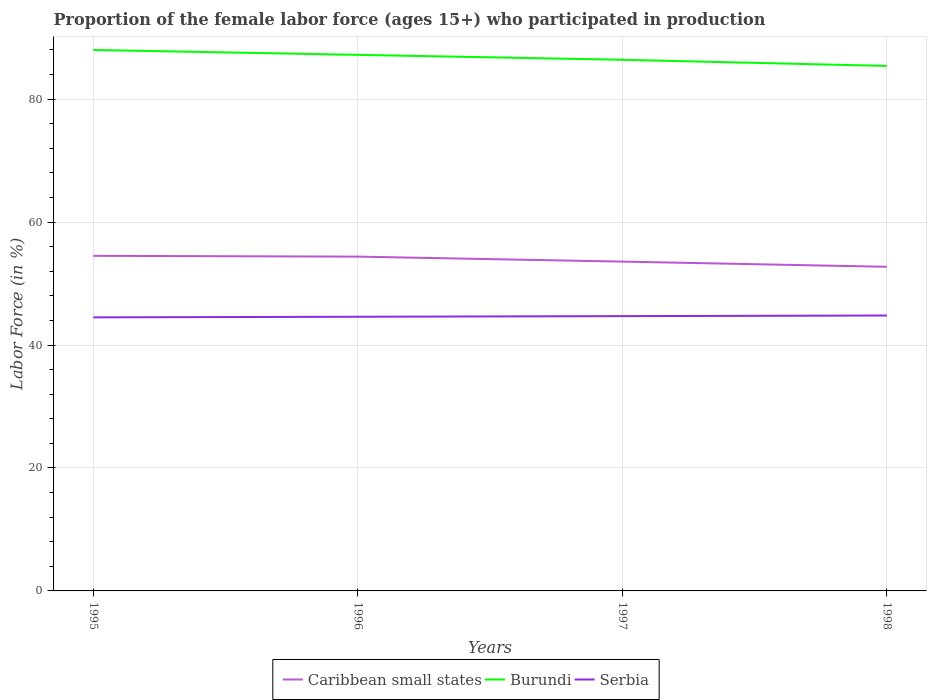How many different coloured lines are there?
Provide a succinct answer. 3. Does the line corresponding to Caribbean small states intersect with the line corresponding to Burundi?
Give a very brief answer. No. Is the number of lines equal to the number of legend labels?
Ensure brevity in your answer.  Yes. Across all years, what is the maximum proportion of the female labor force who participated in production in Caribbean small states?
Offer a very short reply. 52.73. What is the total proportion of the female labor force who participated in production in Burundi in the graph?
Offer a very short reply. 1.8. What is the difference between the highest and the second highest proportion of the female labor force who participated in production in Serbia?
Keep it short and to the point. 0.3. What is the difference between the highest and the lowest proportion of the female labor force who participated in production in Burundi?
Give a very brief answer. 2. How many lines are there?
Provide a short and direct response. 3. How many years are there in the graph?
Offer a terse response. 4. Are the values on the major ticks of Y-axis written in scientific E-notation?
Provide a short and direct response. No. Does the graph contain grids?
Offer a very short reply. Yes. Where does the legend appear in the graph?
Make the answer very short. Bottom center. What is the title of the graph?
Provide a short and direct response. Proportion of the female labor force (ages 15+) who participated in production. What is the label or title of the Y-axis?
Provide a succinct answer. Labor Force (in %). What is the Labor Force (in %) in Caribbean small states in 1995?
Your answer should be compact. 54.51. What is the Labor Force (in %) of Serbia in 1995?
Give a very brief answer. 44.5. What is the Labor Force (in %) in Caribbean small states in 1996?
Give a very brief answer. 54.38. What is the Labor Force (in %) of Burundi in 1996?
Give a very brief answer. 87.2. What is the Labor Force (in %) in Serbia in 1996?
Give a very brief answer. 44.6. What is the Labor Force (in %) in Caribbean small states in 1997?
Your answer should be compact. 53.57. What is the Labor Force (in %) of Burundi in 1997?
Your answer should be compact. 86.4. What is the Labor Force (in %) in Serbia in 1997?
Provide a succinct answer. 44.7. What is the Labor Force (in %) of Caribbean small states in 1998?
Provide a succinct answer. 52.73. What is the Labor Force (in %) of Burundi in 1998?
Offer a very short reply. 85.4. What is the Labor Force (in %) in Serbia in 1998?
Your answer should be very brief. 44.8. Across all years, what is the maximum Labor Force (in %) in Caribbean small states?
Ensure brevity in your answer.  54.51. Across all years, what is the maximum Labor Force (in %) in Burundi?
Provide a short and direct response. 88. Across all years, what is the maximum Labor Force (in %) of Serbia?
Make the answer very short. 44.8. Across all years, what is the minimum Labor Force (in %) in Caribbean small states?
Keep it short and to the point. 52.73. Across all years, what is the minimum Labor Force (in %) in Burundi?
Your answer should be compact. 85.4. Across all years, what is the minimum Labor Force (in %) of Serbia?
Give a very brief answer. 44.5. What is the total Labor Force (in %) in Caribbean small states in the graph?
Ensure brevity in your answer.  215.19. What is the total Labor Force (in %) of Burundi in the graph?
Offer a very short reply. 347. What is the total Labor Force (in %) of Serbia in the graph?
Offer a very short reply. 178.6. What is the difference between the Labor Force (in %) in Caribbean small states in 1995 and that in 1996?
Offer a terse response. 0.13. What is the difference between the Labor Force (in %) in Burundi in 1995 and that in 1996?
Provide a short and direct response. 0.8. What is the difference between the Labor Force (in %) of Serbia in 1995 and that in 1996?
Give a very brief answer. -0.1. What is the difference between the Labor Force (in %) in Caribbean small states in 1995 and that in 1997?
Keep it short and to the point. 0.94. What is the difference between the Labor Force (in %) in Burundi in 1995 and that in 1997?
Your response must be concise. 1.6. What is the difference between the Labor Force (in %) in Serbia in 1995 and that in 1997?
Make the answer very short. -0.2. What is the difference between the Labor Force (in %) of Caribbean small states in 1995 and that in 1998?
Your answer should be very brief. 1.78. What is the difference between the Labor Force (in %) in Serbia in 1995 and that in 1998?
Your response must be concise. -0.3. What is the difference between the Labor Force (in %) in Caribbean small states in 1996 and that in 1997?
Make the answer very short. 0.81. What is the difference between the Labor Force (in %) of Burundi in 1996 and that in 1997?
Offer a terse response. 0.8. What is the difference between the Labor Force (in %) in Serbia in 1996 and that in 1997?
Offer a very short reply. -0.1. What is the difference between the Labor Force (in %) in Caribbean small states in 1996 and that in 1998?
Keep it short and to the point. 1.65. What is the difference between the Labor Force (in %) of Burundi in 1996 and that in 1998?
Provide a short and direct response. 1.8. What is the difference between the Labor Force (in %) of Serbia in 1996 and that in 1998?
Make the answer very short. -0.2. What is the difference between the Labor Force (in %) of Caribbean small states in 1997 and that in 1998?
Give a very brief answer. 0.84. What is the difference between the Labor Force (in %) of Burundi in 1997 and that in 1998?
Offer a very short reply. 1. What is the difference between the Labor Force (in %) in Serbia in 1997 and that in 1998?
Give a very brief answer. -0.1. What is the difference between the Labor Force (in %) in Caribbean small states in 1995 and the Labor Force (in %) in Burundi in 1996?
Offer a very short reply. -32.69. What is the difference between the Labor Force (in %) in Caribbean small states in 1995 and the Labor Force (in %) in Serbia in 1996?
Give a very brief answer. 9.91. What is the difference between the Labor Force (in %) of Burundi in 1995 and the Labor Force (in %) of Serbia in 1996?
Keep it short and to the point. 43.4. What is the difference between the Labor Force (in %) in Caribbean small states in 1995 and the Labor Force (in %) in Burundi in 1997?
Keep it short and to the point. -31.89. What is the difference between the Labor Force (in %) of Caribbean small states in 1995 and the Labor Force (in %) of Serbia in 1997?
Offer a terse response. 9.81. What is the difference between the Labor Force (in %) in Burundi in 1995 and the Labor Force (in %) in Serbia in 1997?
Your answer should be very brief. 43.3. What is the difference between the Labor Force (in %) in Caribbean small states in 1995 and the Labor Force (in %) in Burundi in 1998?
Your response must be concise. -30.89. What is the difference between the Labor Force (in %) in Caribbean small states in 1995 and the Labor Force (in %) in Serbia in 1998?
Your answer should be very brief. 9.71. What is the difference between the Labor Force (in %) in Burundi in 1995 and the Labor Force (in %) in Serbia in 1998?
Keep it short and to the point. 43.2. What is the difference between the Labor Force (in %) of Caribbean small states in 1996 and the Labor Force (in %) of Burundi in 1997?
Provide a short and direct response. -32.02. What is the difference between the Labor Force (in %) of Caribbean small states in 1996 and the Labor Force (in %) of Serbia in 1997?
Provide a succinct answer. 9.68. What is the difference between the Labor Force (in %) in Burundi in 1996 and the Labor Force (in %) in Serbia in 1997?
Make the answer very short. 42.5. What is the difference between the Labor Force (in %) in Caribbean small states in 1996 and the Labor Force (in %) in Burundi in 1998?
Your answer should be compact. -31.02. What is the difference between the Labor Force (in %) of Caribbean small states in 1996 and the Labor Force (in %) of Serbia in 1998?
Ensure brevity in your answer.  9.58. What is the difference between the Labor Force (in %) of Burundi in 1996 and the Labor Force (in %) of Serbia in 1998?
Make the answer very short. 42.4. What is the difference between the Labor Force (in %) of Caribbean small states in 1997 and the Labor Force (in %) of Burundi in 1998?
Your response must be concise. -31.83. What is the difference between the Labor Force (in %) in Caribbean small states in 1997 and the Labor Force (in %) in Serbia in 1998?
Ensure brevity in your answer.  8.77. What is the difference between the Labor Force (in %) of Burundi in 1997 and the Labor Force (in %) of Serbia in 1998?
Provide a succinct answer. 41.6. What is the average Labor Force (in %) of Caribbean small states per year?
Make the answer very short. 53.8. What is the average Labor Force (in %) in Burundi per year?
Make the answer very short. 86.75. What is the average Labor Force (in %) in Serbia per year?
Ensure brevity in your answer.  44.65. In the year 1995, what is the difference between the Labor Force (in %) in Caribbean small states and Labor Force (in %) in Burundi?
Make the answer very short. -33.49. In the year 1995, what is the difference between the Labor Force (in %) of Caribbean small states and Labor Force (in %) of Serbia?
Offer a very short reply. 10.01. In the year 1995, what is the difference between the Labor Force (in %) of Burundi and Labor Force (in %) of Serbia?
Your answer should be compact. 43.5. In the year 1996, what is the difference between the Labor Force (in %) of Caribbean small states and Labor Force (in %) of Burundi?
Provide a succinct answer. -32.82. In the year 1996, what is the difference between the Labor Force (in %) in Caribbean small states and Labor Force (in %) in Serbia?
Your answer should be very brief. 9.78. In the year 1996, what is the difference between the Labor Force (in %) in Burundi and Labor Force (in %) in Serbia?
Your answer should be compact. 42.6. In the year 1997, what is the difference between the Labor Force (in %) of Caribbean small states and Labor Force (in %) of Burundi?
Provide a short and direct response. -32.83. In the year 1997, what is the difference between the Labor Force (in %) in Caribbean small states and Labor Force (in %) in Serbia?
Offer a very short reply. 8.87. In the year 1997, what is the difference between the Labor Force (in %) of Burundi and Labor Force (in %) of Serbia?
Give a very brief answer. 41.7. In the year 1998, what is the difference between the Labor Force (in %) of Caribbean small states and Labor Force (in %) of Burundi?
Keep it short and to the point. -32.67. In the year 1998, what is the difference between the Labor Force (in %) in Caribbean small states and Labor Force (in %) in Serbia?
Give a very brief answer. 7.93. In the year 1998, what is the difference between the Labor Force (in %) in Burundi and Labor Force (in %) in Serbia?
Your answer should be compact. 40.6. What is the ratio of the Labor Force (in %) of Burundi in 1995 to that in 1996?
Provide a succinct answer. 1.01. What is the ratio of the Labor Force (in %) in Caribbean small states in 1995 to that in 1997?
Provide a short and direct response. 1.02. What is the ratio of the Labor Force (in %) in Burundi in 1995 to that in 1997?
Make the answer very short. 1.02. What is the ratio of the Labor Force (in %) in Serbia in 1995 to that in 1997?
Keep it short and to the point. 1. What is the ratio of the Labor Force (in %) of Caribbean small states in 1995 to that in 1998?
Offer a very short reply. 1.03. What is the ratio of the Labor Force (in %) in Burundi in 1995 to that in 1998?
Make the answer very short. 1.03. What is the ratio of the Labor Force (in %) of Caribbean small states in 1996 to that in 1997?
Keep it short and to the point. 1.02. What is the ratio of the Labor Force (in %) in Burundi in 1996 to that in 1997?
Keep it short and to the point. 1.01. What is the ratio of the Labor Force (in %) of Caribbean small states in 1996 to that in 1998?
Provide a succinct answer. 1.03. What is the ratio of the Labor Force (in %) of Burundi in 1996 to that in 1998?
Offer a terse response. 1.02. What is the ratio of the Labor Force (in %) in Serbia in 1996 to that in 1998?
Provide a succinct answer. 1. What is the ratio of the Labor Force (in %) in Caribbean small states in 1997 to that in 1998?
Provide a short and direct response. 1.02. What is the ratio of the Labor Force (in %) of Burundi in 1997 to that in 1998?
Ensure brevity in your answer.  1.01. What is the difference between the highest and the second highest Labor Force (in %) in Caribbean small states?
Offer a very short reply. 0.13. What is the difference between the highest and the second highest Labor Force (in %) in Burundi?
Provide a short and direct response. 0.8. What is the difference between the highest and the lowest Labor Force (in %) in Caribbean small states?
Your answer should be compact. 1.78. What is the difference between the highest and the lowest Labor Force (in %) of Burundi?
Your response must be concise. 2.6. What is the difference between the highest and the lowest Labor Force (in %) of Serbia?
Offer a terse response. 0.3. 